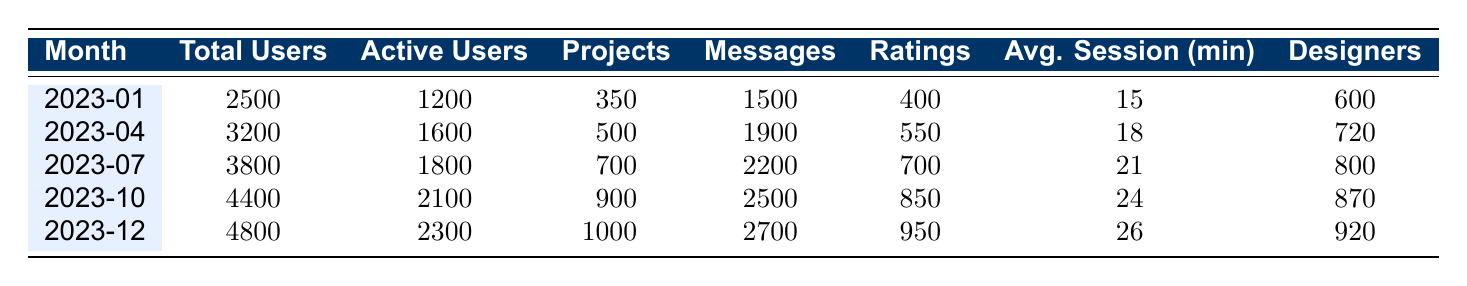What was the total number of users in March 2023? In the table, the value under "Total Users" for March 2023 is listed as 3000.
Answer: 3000 How many projects were created in December 2023? The "Projects" column for December 2023 shows a value of 1000.
Answer: 1000 What was the average session duration in November 2023? For November 2023, the "Avg. Session (min)" value is 25.
Answer: 25 Which month had the highest number of active users? Scanning the "Active Users" column, December 2023 has the highest value of 2300 compared to other months.
Answer: December 2023 What is the percentage increase in total users from January 2023 to December 2023? Total users in January 2023 are 2500 and in December 2023 are 4800. The increase is (4800 - 2500) / 2500 * 100 = 92%.
Answer: 92% Did the number of ratings given exceed 800 in any month? Looking at the "Ratings" column, the value exceeds 800 in December 2023, which has 950 ratings.
Answer: Yes How many more projects were created in October 2023 than in April 2023? In October 2023, 900 projects were created and in April 2023, 500 were created. The difference is 900 - 500 = 400.
Answer: 400 What month had the lowest average session duration? The "Avg. Session (min)" values indicate January 2023 with 15 minutes as the lowest.
Answer: January 2023 What was the total number of messages sent in the period from January to June 2023? By summing the "Messages" column from January (1500) to June (2100), the total is 1500 + 1600 + 1800 + 1900 + 2000 + 2100 = 10900.
Answer: 10900 Which month showed the largest increase in unique designers? Analyzing the "Designers" column, we find that the increase from April (720) to May (750) is 30, which is smaller than the increase from October (870) to December (920) which is 50.
Answer: October to December 2023 